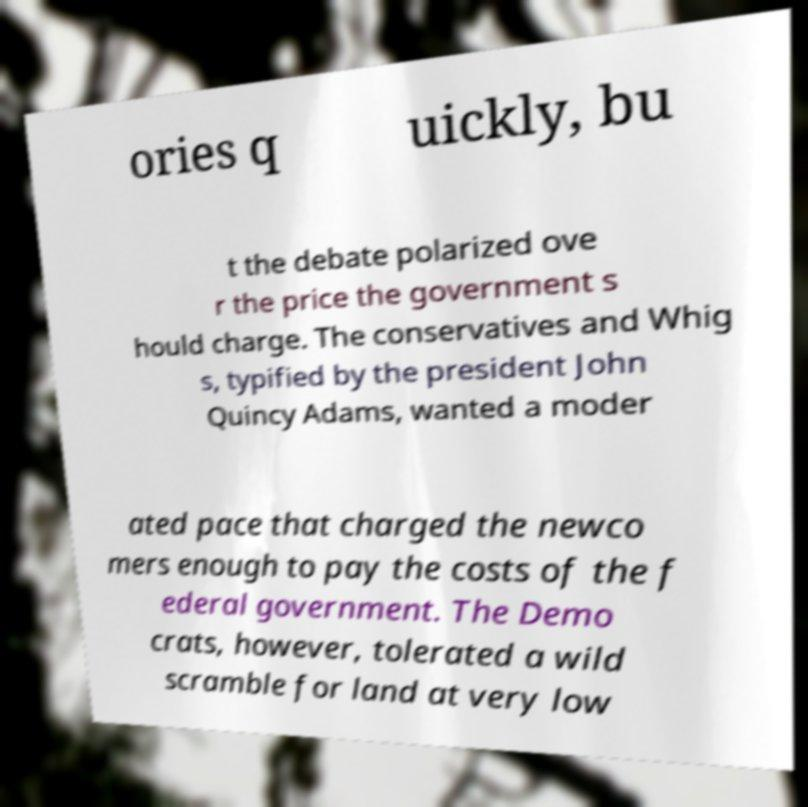Can you accurately transcribe the text from the provided image for me? ories q uickly, bu t the debate polarized ove r the price the government s hould charge. The conservatives and Whig s, typified by the president John Quincy Adams, wanted a moder ated pace that charged the newco mers enough to pay the costs of the f ederal government. The Demo crats, however, tolerated a wild scramble for land at very low 